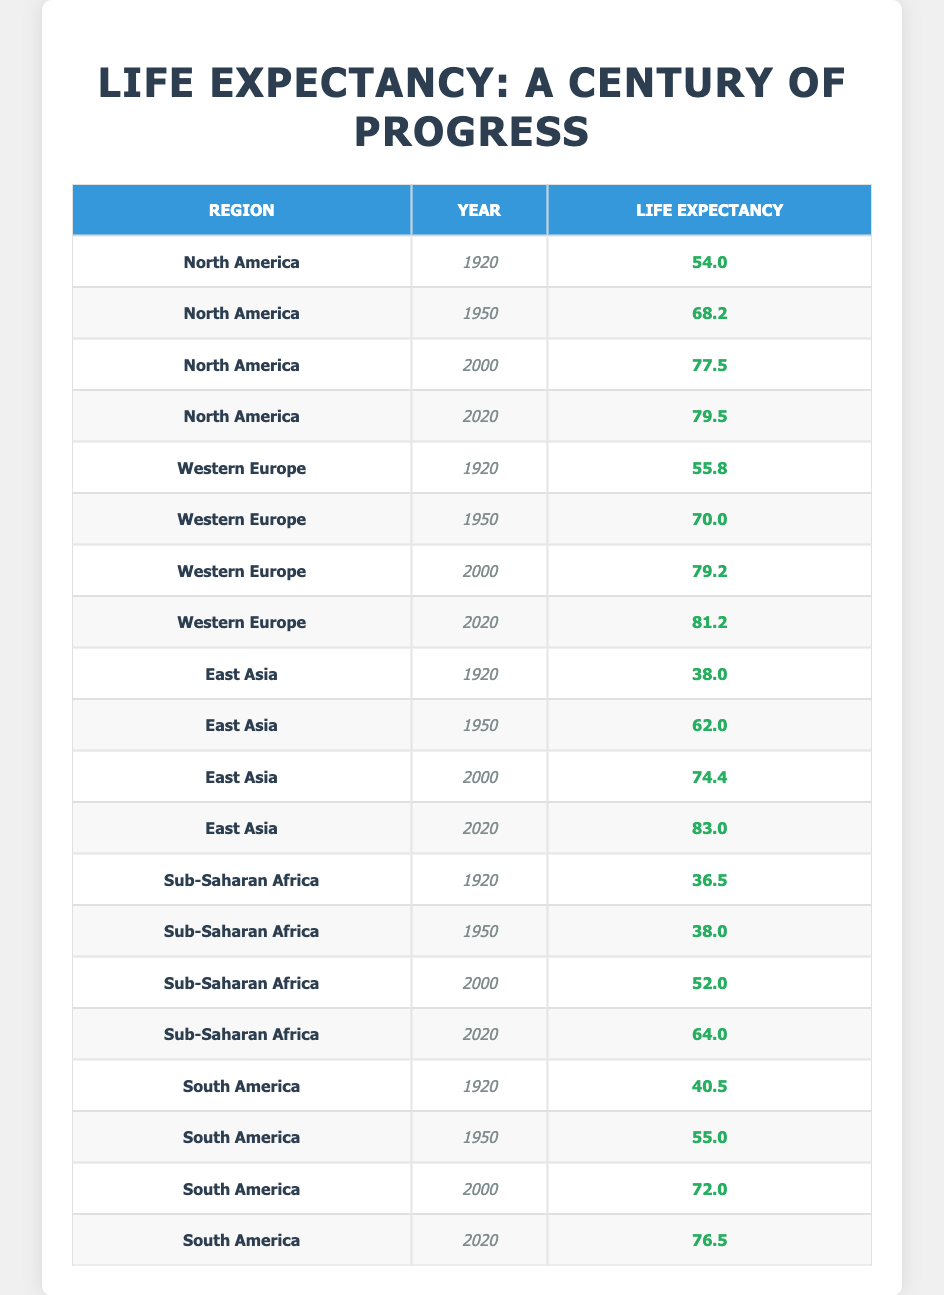What was the life expectancy in North America in 1920? From the table, I can see that for the region of North America, the year is listed as 1920 and the life expectancy is provided as 54.0.
Answer: 54.0 What is the life expectancy of Western Europe in 2000? By checking the table for Western Europe under the year 2000, the life expectancy is clearly noted as 79.2.
Answer: 79.2 Which region had the highest life expectancy in 2020? Reviewing the data for the year 2020, I will look at each region: North America (79.5), Western Europe (81.2), East Asia (83.0), and Sub-Saharan Africa (64.0). East Asia has the highest life expectancy of 83.0.
Answer: East Asia How much did life expectancy increase in Sub-Saharan Africa from 2000 to 2020? In the table, I find the life expectancy for Sub-Saharan Africa in 2000 is 52.0 and in 2020 it is 64.0. The increase can be calculated as 64.0 - 52.0 = 12.0.
Answer: 12.0 Is it true that South America's life expectancy was higher than North America's in 1950? Checking the table, I see that South America's life expectancy in 1950 was 55.0, while North America's life expectancy that same year was 68.2. Thus, South America did not have a higher life expectancy than North America in 1950.
Answer: No What was the average life expectancy across all regions in 2000? I sum the life expectancies for all regions in 2000: North America (77.5), Western Europe (79.2), East Asia (74.4), Sub-Saharan Africa (52.0), and South America (72.0). The total is 77.5 + 79.2 + 74.4 + 52.0 + 72.0 = 355.1. To find the average, I divide by 5 regions, resulting in 355.1 / 5 = 71.02.
Answer: 71.02 Which region showed the most significant improvement in life expectancy from 1920 to 2020? I analyze the data: North America increased from 54.0 to 79.5 (25.5), Western Europe from 55.8 to 81.2 (25.4), East Asia from 38.0 to 83.0 (45.0), Sub-Saharan Africa from 36.5 to 64.0 (27.5), and South America from 40.5 to 76.5 (36.0). East Asia demonstrates the most significant improvement of 45.0.
Answer: East Asia 